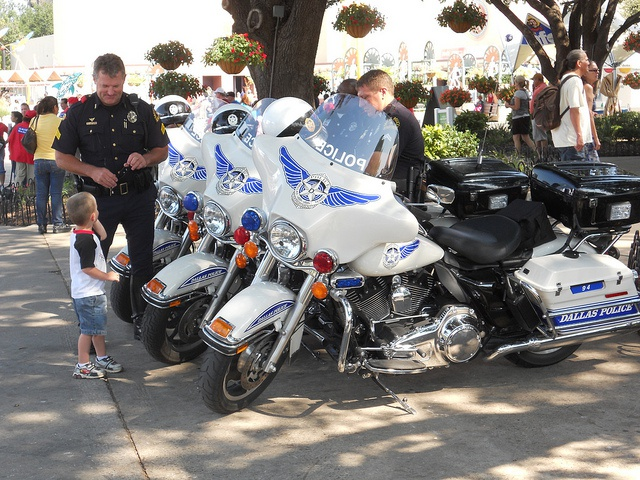Describe the objects in this image and their specific colors. I can see motorcycle in white, black, lightgray, gray, and darkgray tones, people in white, black, brown, gray, and maroon tones, motorcycle in lightgray, black, darkgray, and gray tones, people in white, black, gray, and darkgray tones, and people in white, gray, lavender, and black tones in this image. 